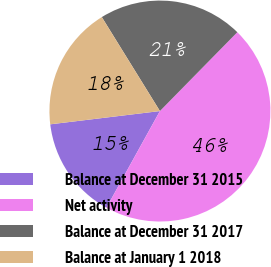Convert chart to OTSL. <chart><loc_0><loc_0><loc_500><loc_500><pie_chart><fcel>Balance at December 31 2015<fcel>Net activity<fcel>Balance at December 31 2017<fcel>Balance at January 1 2018<nl><fcel>15.04%<fcel>45.69%<fcel>21.17%<fcel>18.1%<nl></chart> 